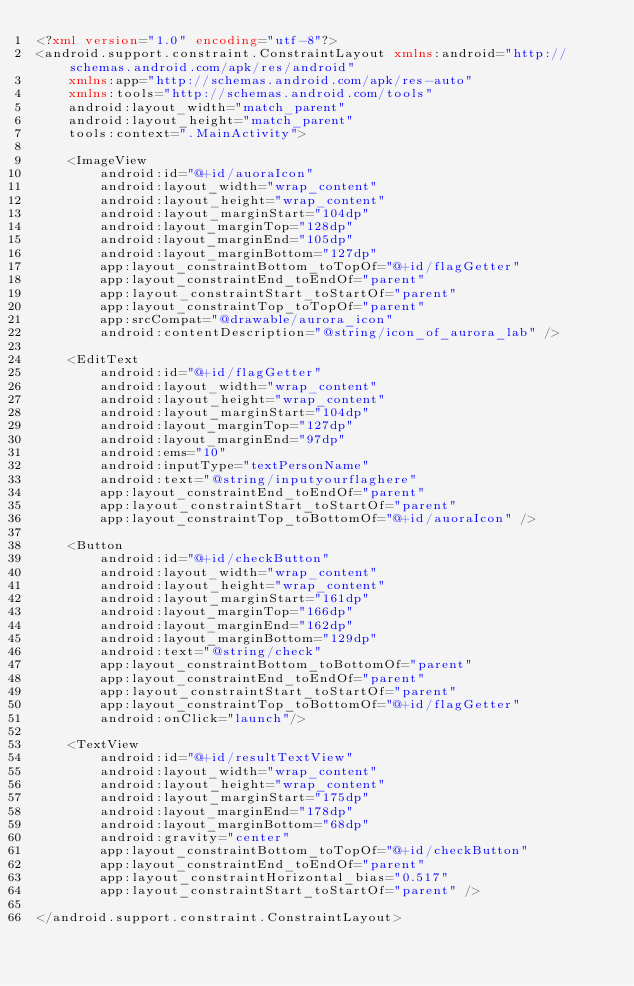<code> <loc_0><loc_0><loc_500><loc_500><_XML_><?xml version="1.0" encoding="utf-8"?>
<android.support.constraint.ConstraintLayout xmlns:android="http://schemas.android.com/apk/res/android"
    xmlns:app="http://schemas.android.com/apk/res-auto"
    xmlns:tools="http://schemas.android.com/tools"
    android:layout_width="match_parent"
    android:layout_height="match_parent"
    tools:context=".MainActivity">

    <ImageView
        android:id="@+id/auoraIcon"
        android:layout_width="wrap_content"
        android:layout_height="wrap_content"
        android:layout_marginStart="104dp"
        android:layout_marginTop="128dp"
        android:layout_marginEnd="105dp"
        android:layout_marginBottom="127dp"
        app:layout_constraintBottom_toTopOf="@+id/flagGetter"
        app:layout_constraintEnd_toEndOf="parent"
        app:layout_constraintStart_toStartOf="parent"
        app:layout_constraintTop_toTopOf="parent"
        app:srcCompat="@drawable/aurora_icon"
        android:contentDescription="@string/icon_of_aurora_lab" />

    <EditText
        android:id="@+id/flagGetter"
        android:layout_width="wrap_content"
        android:layout_height="wrap_content"
        android:layout_marginStart="104dp"
        android:layout_marginTop="127dp"
        android:layout_marginEnd="97dp"
        android:ems="10"
        android:inputType="textPersonName"
        android:text="@string/inputyourflaghere"
        app:layout_constraintEnd_toEndOf="parent"
        app:layout_constraintStart_toStartOf="parent"
        app:layout_constraintTop_toBottomOf="@+id/auoraIcon" />

    <Button
        android:id="@+id/checkButton"
        android:layout_width="wrap_content"
        android:layout_height="wrap_content"
        android:layout_marginStart="161dp"
        android:layout_marginTop="166dp"
        android:layout_marginEnd="162dp"
        android:layout_marginBottom="129dp"
        android:text="@string/check"
        app:layout_constraintBottom_toBottomOf="parent"
        app:layout_constraintEnd_toEndOf="parent"
        app:layout_constraintStart_toStartOf="parent"
        app:layout_constraintTop_toBottomOf="@+id/flagGetter"
        android:onClick="launch"/>

    <TextView
        android:id="@+id/resultTextView"
        android:layout_width="wrap_content"
        android:layout_height="wrap_content"
        android:layout_marginStart="175dp"
        android:layout_marginEnd="178dp"
        android:layout_marginBottom="68dp"
        android:gravity="center"
        app:layout_constraintBottom_toTopOf="@+id/checkButton"
        app:layout_constraintEnd_toEndOf="parent"
        app:layout_constraintHorizontal_bias="0.517"
        app:layout_constraintStart_toStartOf="parent" />

</android.support.constraint.ConstraintLayout></code> 